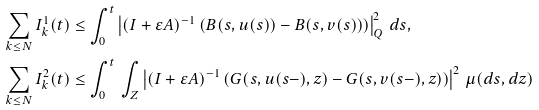Convert formula to latex. <formula><loc_0><loc_0><loc_500><loc_500>\sum _ { k \leq N } I ^ { 1 } _ { k } ( t ) & \leq \int _ { 0 } ^ { t } \left | ( I + \varepsilon A ) ^ { - 1 } \left ( B ( s , u ( s ) ) - B ( s , v ( s ) ) \right ) \right | _ { Q } ^ { 2 } \, d s , \\ \sum _ { k \leq N } I ^ { 2 } _ { k } ( t ) & \leq \int _ { 0 } ^ { t } \, \int _ { Z } \left | ( I + \varepsilon A ) ^ { - 1 } \left ( G ( s , u ( s - ) , z ) - G ( s , v ( s - ) , z ) \right ) \right | ^ { 2 } \, \mu ( d s , d z )</formula> 